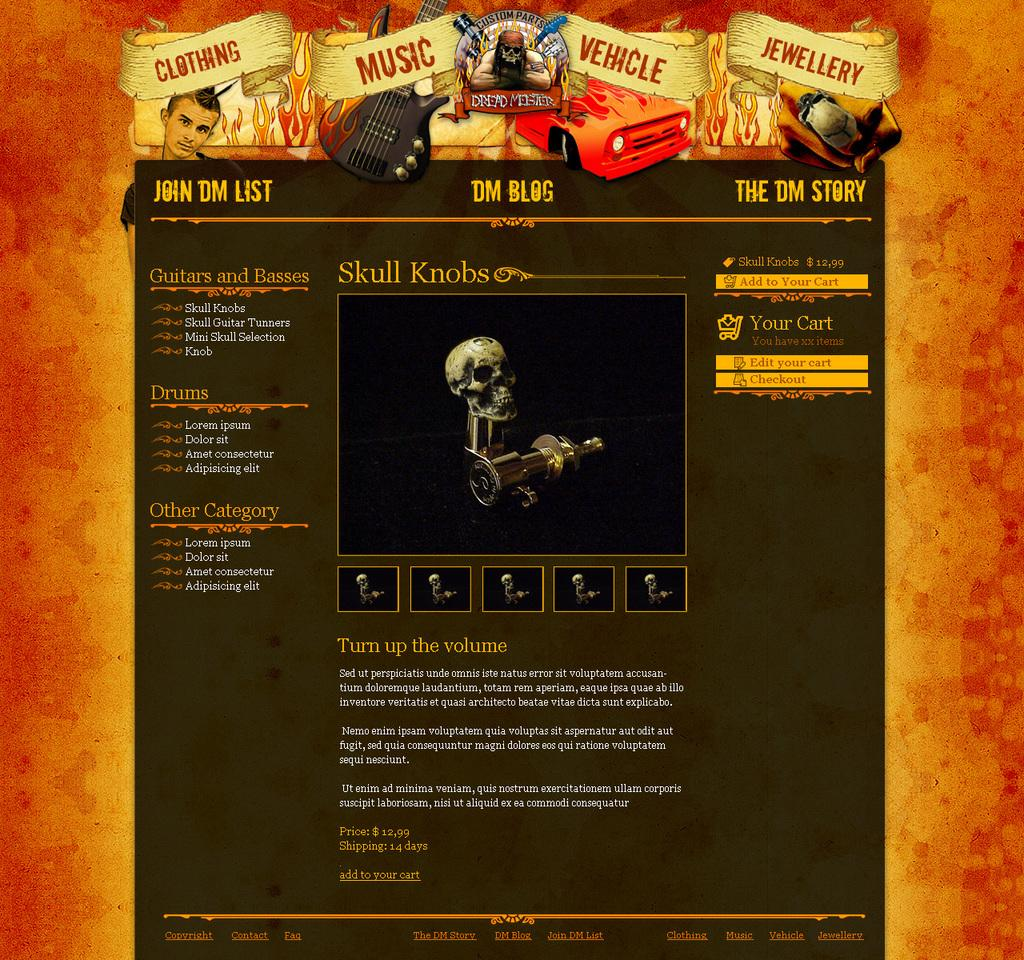What is depicted on the poster in the image? The poster contains a skeleton and a person. What can be found at the bottom of the poster? There are articles at the bottom of the poster. How does the poster help to increase the drainage system in the image? The poster does not depict or relate to any drainage system in the image. 